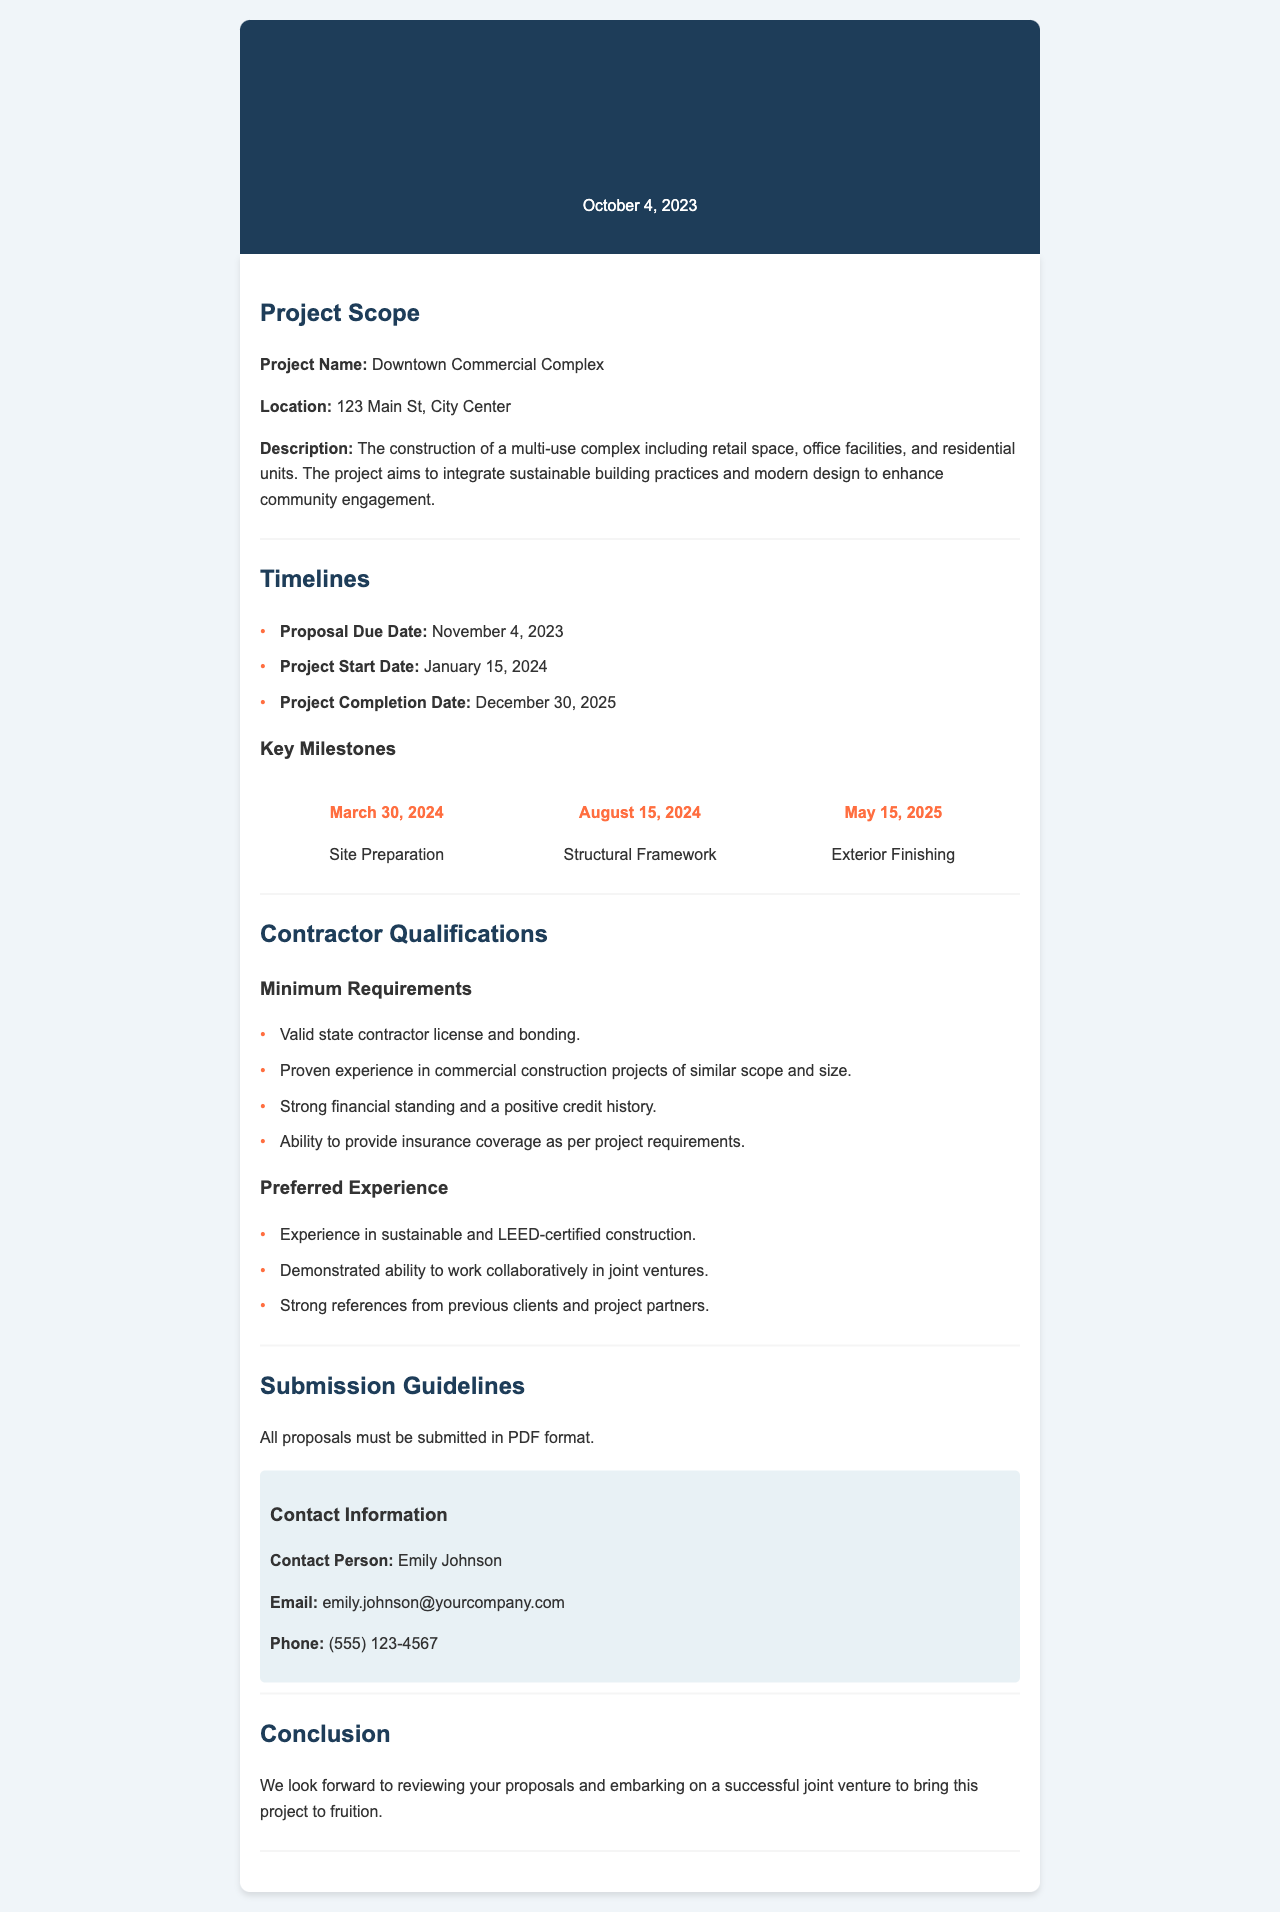what is the project name? The project name is mentioned in the project scope section.
Answer: Downtown Commercial Complex what is the location of the project? The location is outlined in the project scope section.
Answer: 123 Main St, City Center what is the proposal due date? The due date for proposals is stated in the timelines section.
Answer: November 4, 2023 when is the project expected to start? The project start date can be found in the timelines section.
Answer: January 15, 2024 what is a minimum requirement for the contractor? Minimum requirements for contractors are listed under contractor qualifications.
Answer: Valid state contractor license and bonding what experience is preferred for contractors? Preferred experience for contractors is detailed under contractor qualifications.
Answer: Experience in sustainable and LEED-certified construction which person should proposals be submitted to? The contact person for these proposals is mentioned in the submission guidelines.
Answer: Emily Johnson what format should proposals be submitted in? The format for submission is stated in the submission guidelines section.
Answer: PDF format what is the project completion date? The project completion date is mentioned in the timelines section.
Answer: December 30, 2025 